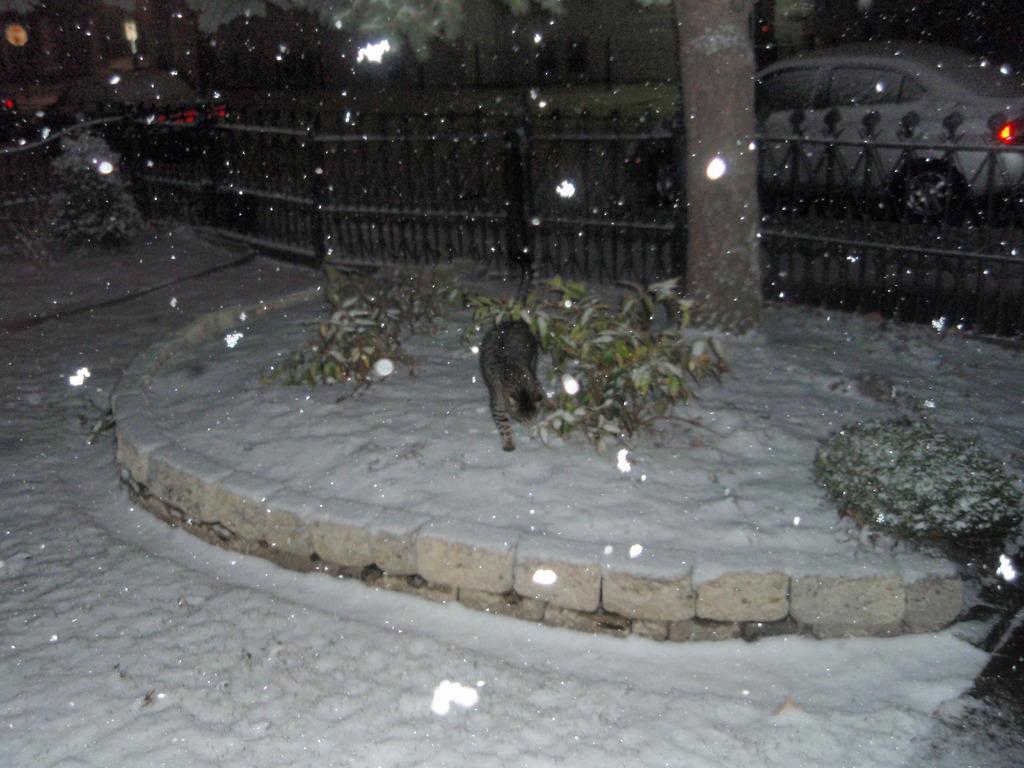How would you summarize this image in a sentence or two? In this image I can see a cat and plants on the road and also I can see a fence. In the background I can see trees, vehicles on the road, tree trunks, snow and lights. This image is taken, may be during night. 